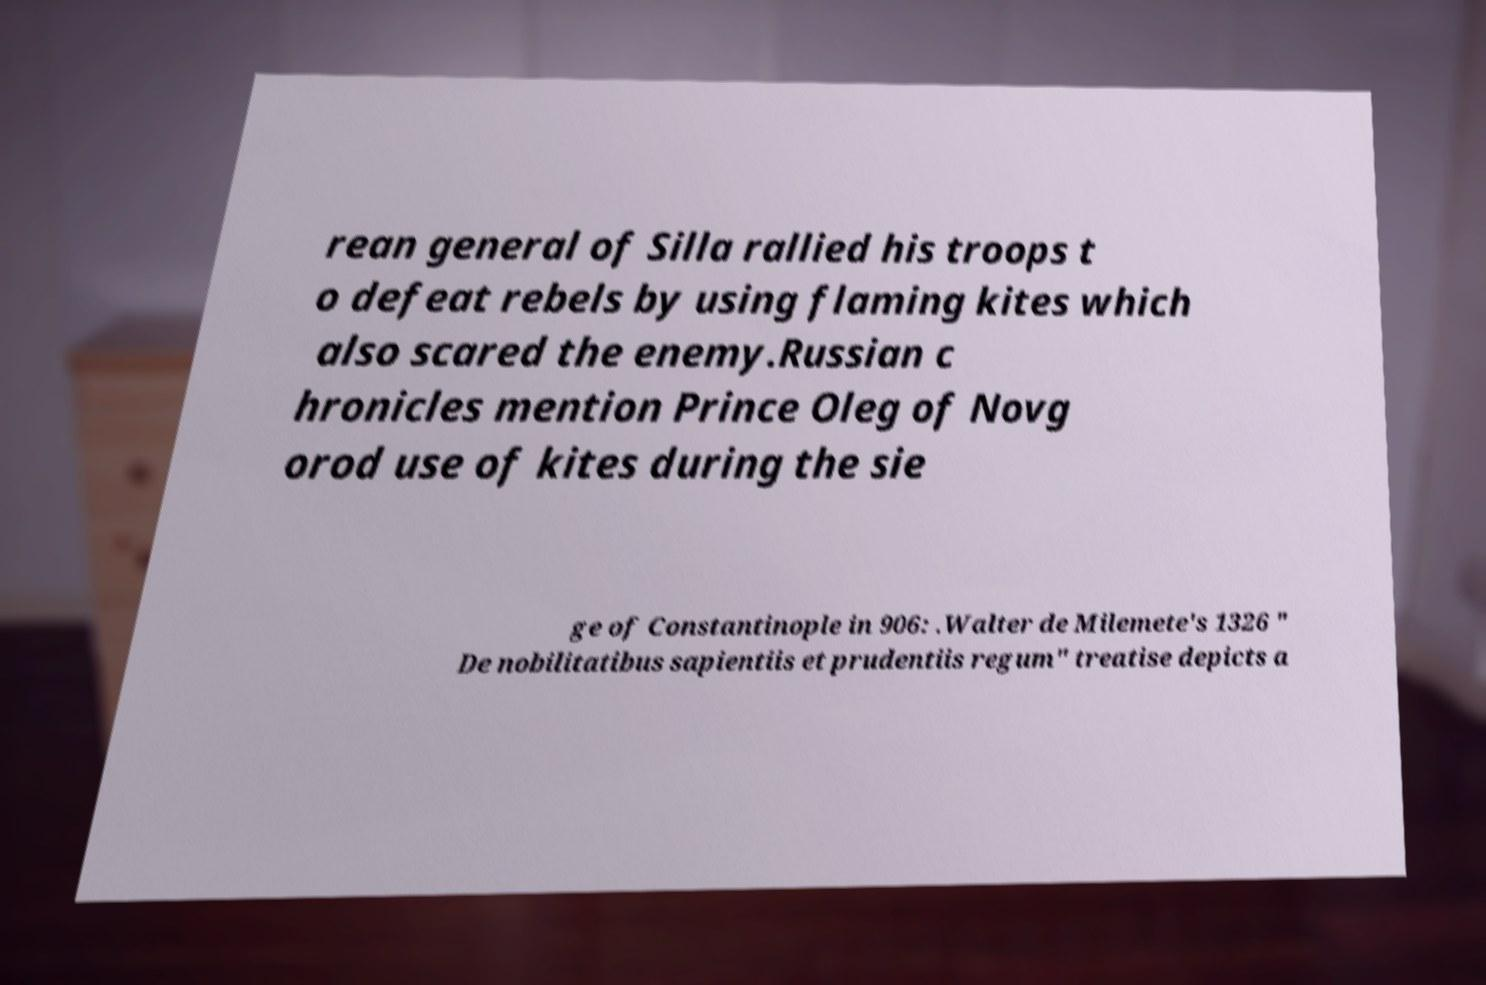Can you accurately transcribe the text from the provided image for me? rean general of Silla rallied his troops t o defeat rebels by using flaming kites which also scared the enemy.Russian c hronicles mention Prince Oleg of Novg orod use of kites during the sie ge of Constantinople in 906: .Walter de Milemete's 1326 " De nobilitatibus sapientiis et prudentiis regum" treatise depicts a 